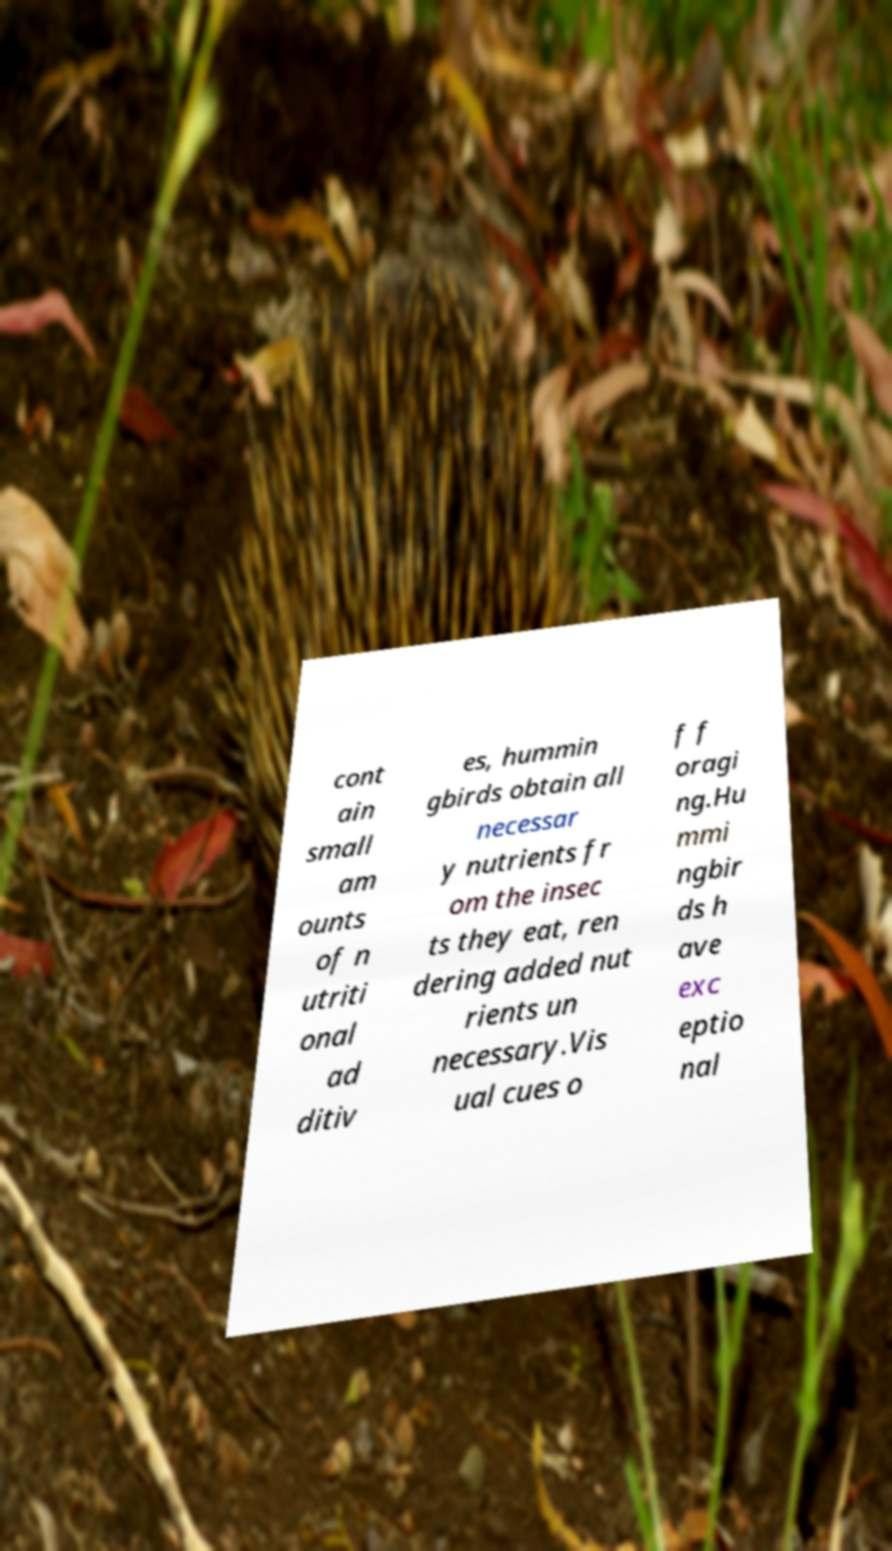Could you assist in decoding the text presented in this image and type it out clearly? cont ain small am ounts of n utriti onal ad ditiv es, hummin gbirds obtain all necessar y nutrients fr om the insec ts they eat, ren dering added nut rients un necessary.Vis ual cues o f f oragi ng.Hu mmi ngbir ds h ave exc eptio nal 